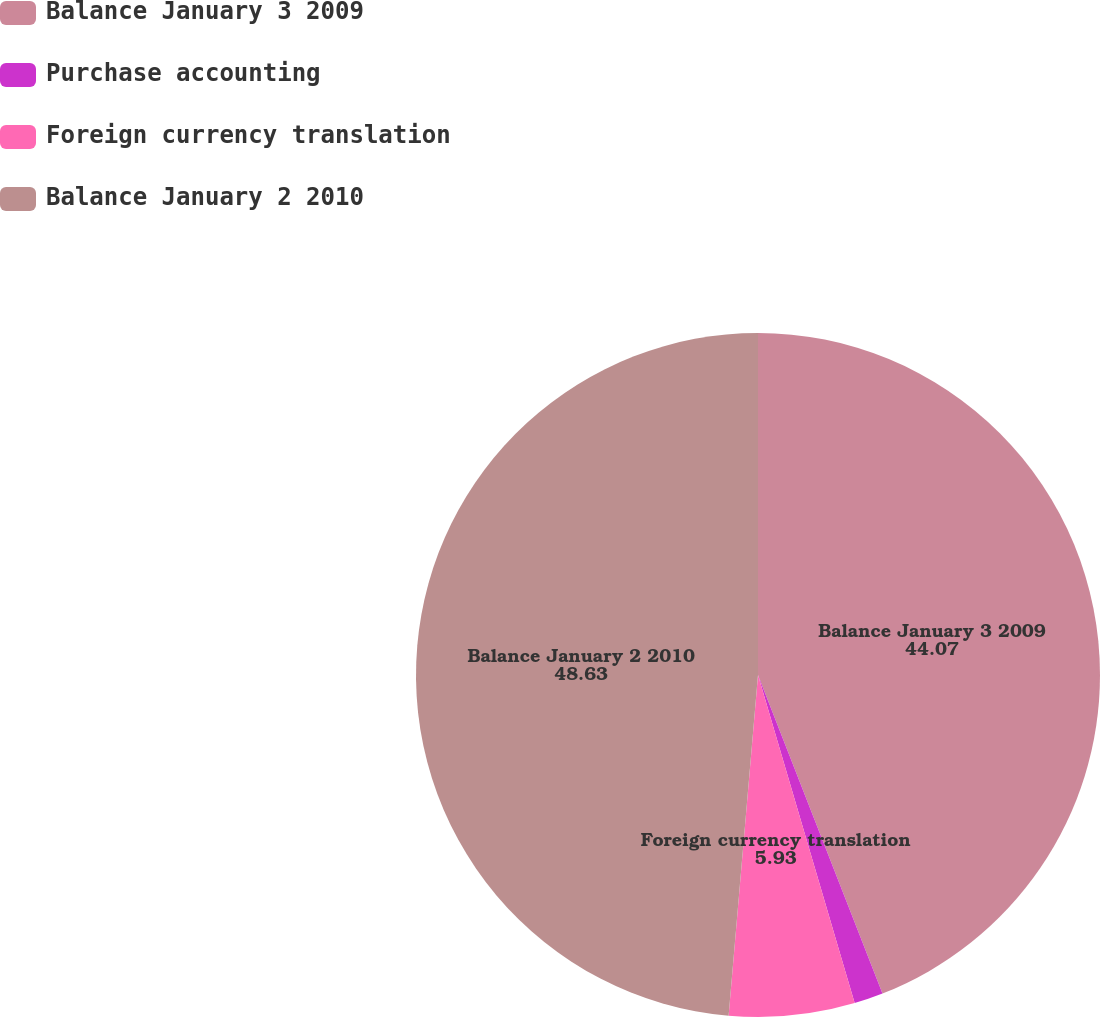Convert chart. <chart><loc_0><loc_0><loc_500><loc_500><pie_chart><fcel>Balance January 3 2009<fcel>Purchase accounting<fcel>Foreign currency translation<fcel>Balance January 2 2010<nl><fcel>44.07%<fcel>1.37%<fcel>5.93%<fcel>48.63%<nl></chart> 